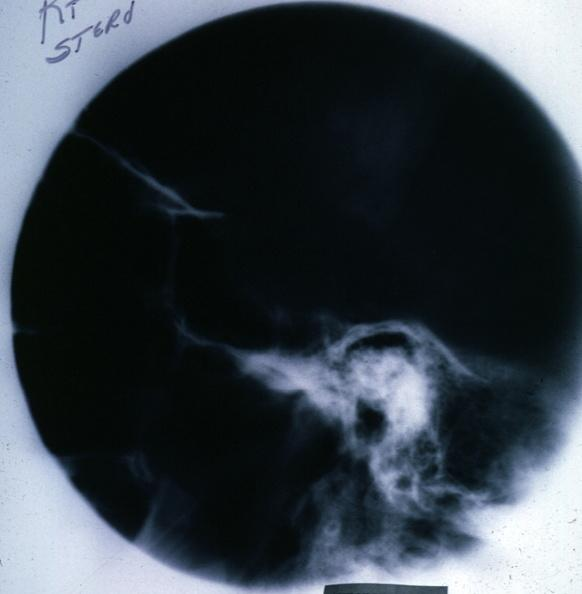s chromophobe adenoma present?
Answer the question using a single word or phrase. Yes 